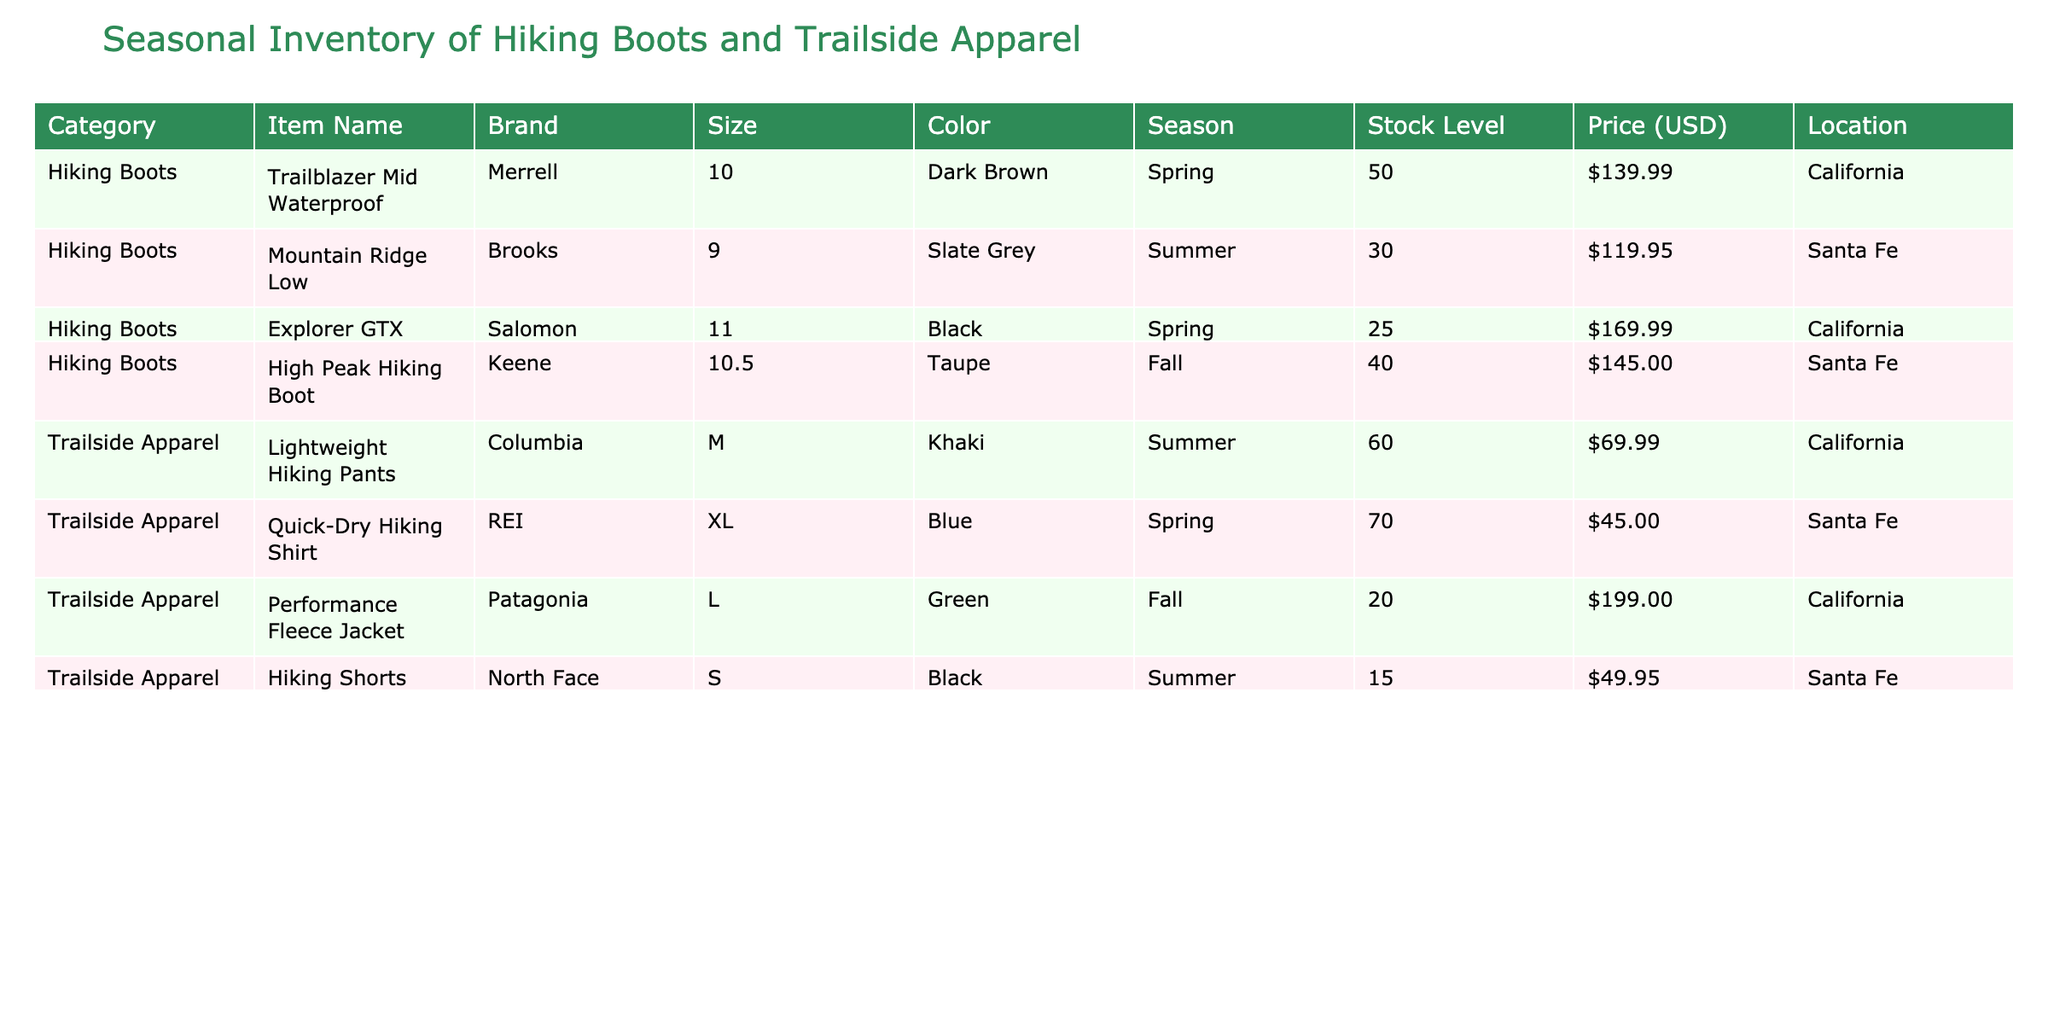What is the stock level of the Trailblazer Mid Waterproof boots in California? The table indicates that the stock level for the Trailblazer Mid Waterproof boots in California is listed directly next to the item name, and it shows as 50.
Answer: 50 What color is the Mountain Ridge Low boot available in Santa Fe? By looking at the item details in the table, the Mountain Ridge Low boot is shown to be in Slate Grey color.
Answer: Slate Grey How many different items are listed for Spring season in California? The table lists the items under the specific season. In California, two items are under Spring: Trailblazer Mid Waterproof and Explorer GTX. Hence, there are 2 items.
Answer: 2 What is the total stock level of Trailside Apparel items in Santa Fe? To derive the total stock level of Trailside Apparel items in Santa Fe, we add the stock levels of the Quick-Dry Hiking Shirt (70) and Hiking Shorts (15), resulting in a total of 70 + 15 = 85.
Answer: 85 Is there any item priced over $200 in the inventory? Reviewing the price column in the table, the only item that is over $200 is the Performance Fleece Jacket, priced at $199. Thus, there is no item exceeding $200.
Answer: No What is the average price of Hiking Boots in this inventory? The prices of the Hiking Boots are $139.99 (Trailblazer Mid Waterproof), $119.95 (Mountain Ridge Low), $169.99 (Explorer GTX), and $145.00 (High Peak Hiking Boot). Calculating the average, we sum the prices: $139.99 + $119.95 + $169.99 + $145.00 = $575.93. Then we divide by the total items: $575.93 / 4 = $143.98.
Answer: 143.98 How many items in total are available in the Summer season? From the table, in the Summer season, we have the Mountain Ridge Low boots (30 stock), Lightweight Hiking Pants (60 stock), and Hiking Shorts (15 stock). Hence, the total count of different items is 3.
Answer: 3 Are there more hiking boots or trailside apparel items available in California? By examining the stock levels, we find there are 3 items counted under Hiking Boots with varying stock levels while there are 3 items under Trailside Apparel. Hence, both categories have an equal number of items.
Answer: Equal 